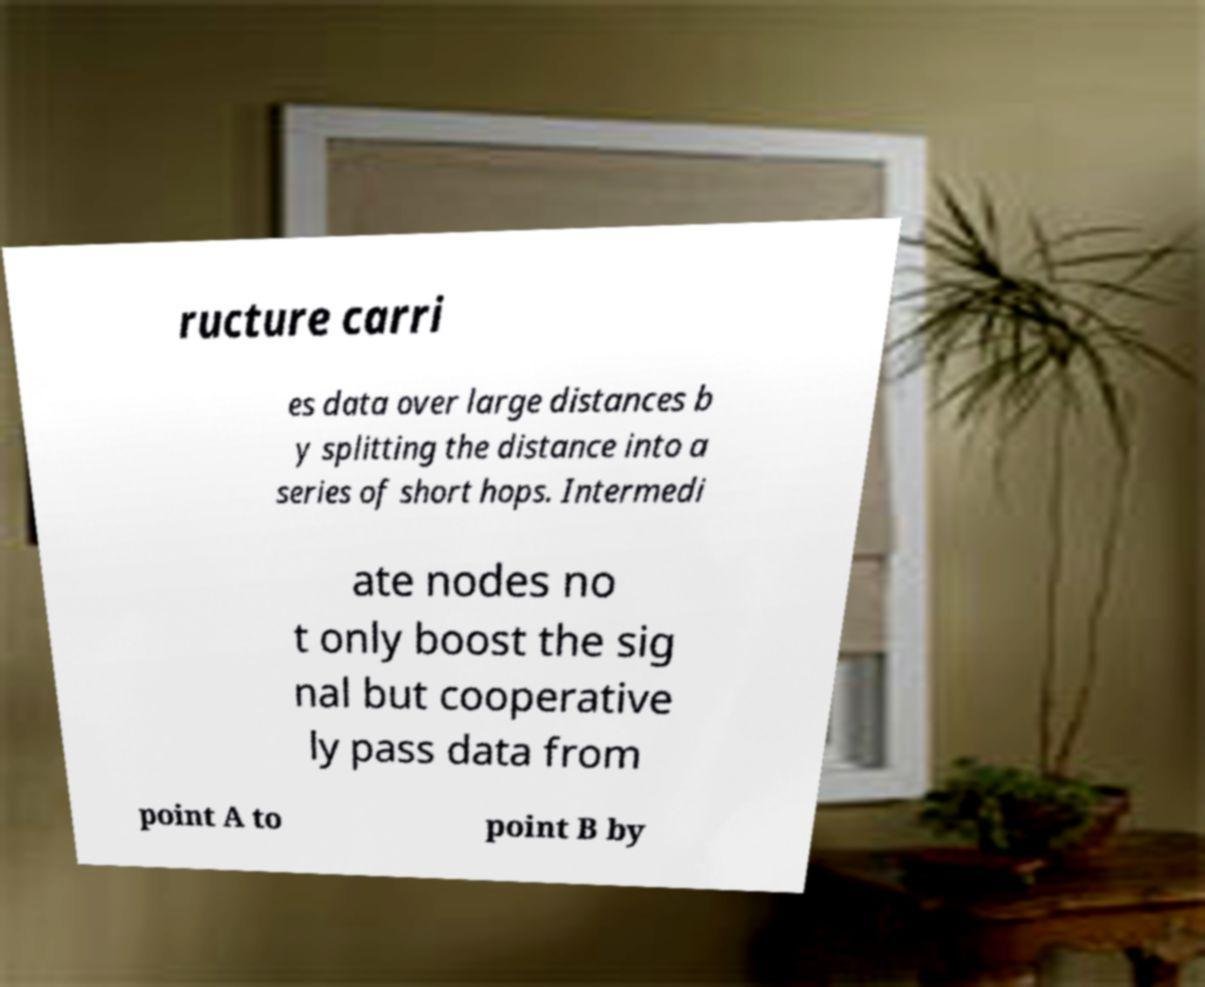Can you accurately transcribe the text from the provided image for me? ructure carri es data over large distances b y splitting the distance into a series of short hops. Intermedi ate nodes no t only boost the sig nal but cooperative ly pass data from point A to point B by 